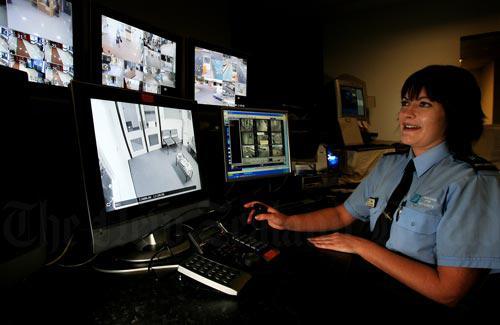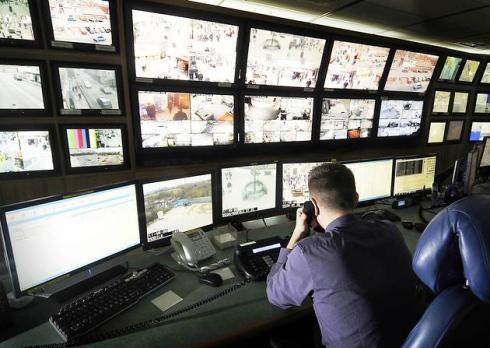The first image is the image on the left, the second image is the image on the right. Analyze the images presented: Is the assertion "An image shows a man reaching to touch a control panel." valid? Answer yes or no. No. The first image is the image on the left, the second image is the image on the right. Examine the images to the left and right. Is the description "An image shows the back of a man seated before many screens." accurate? Answer yes or no. Yes. 